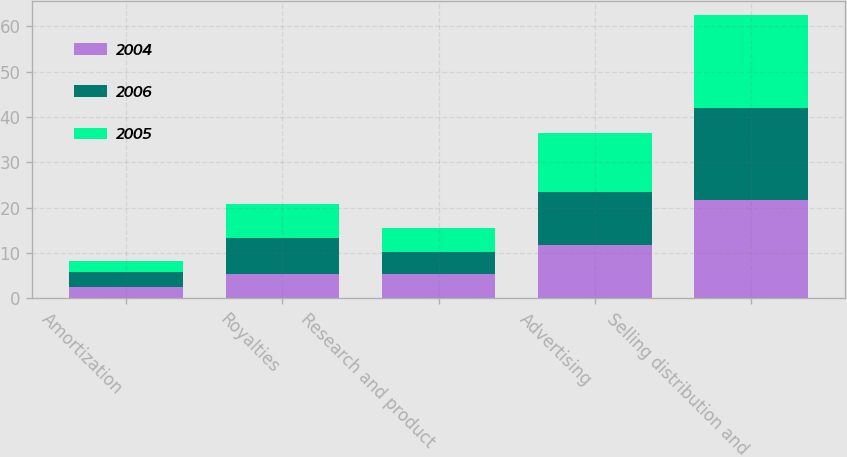<chart> <loc_0><loc_0><loc_500><loc_500><stacked_bar_chart><ecel><fcel>Amortization<fcel>Royalties<fcel>Research and product<fcel>Advertising<fcel>Selling distribution and<nl><fcel>2004<fcel>2.5<fcel>5.4<fcel>5.4<fcel>11.7<fcel>21.7<nl><fcel>2006<fcel>3.3<fcel>8<fcel>4.9<fcel>11.8<fcel>20.2<nl><fcel>2005<fcel>2.4<fcel>7.4<fcel>5.2<fcel>12.9<fcel>20.5<nl></chart> 